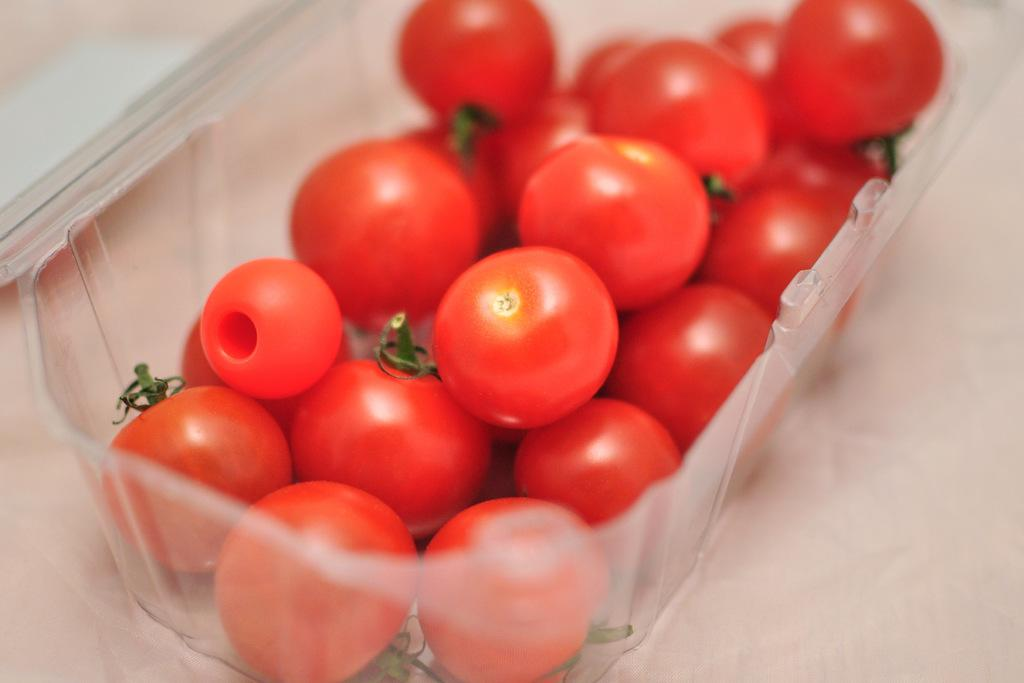What object is present in the image? There is a box in the image. What is inside the box? The box contains red color tomatoes. Can you describe the color of any object in the image? Yes, there is a red color thing in the image, which are the tomatoes. Where is the yak grazing in the image? A: There is no yak present in the image. What type of tub can be seen in the image? There is no tub present in the image. 